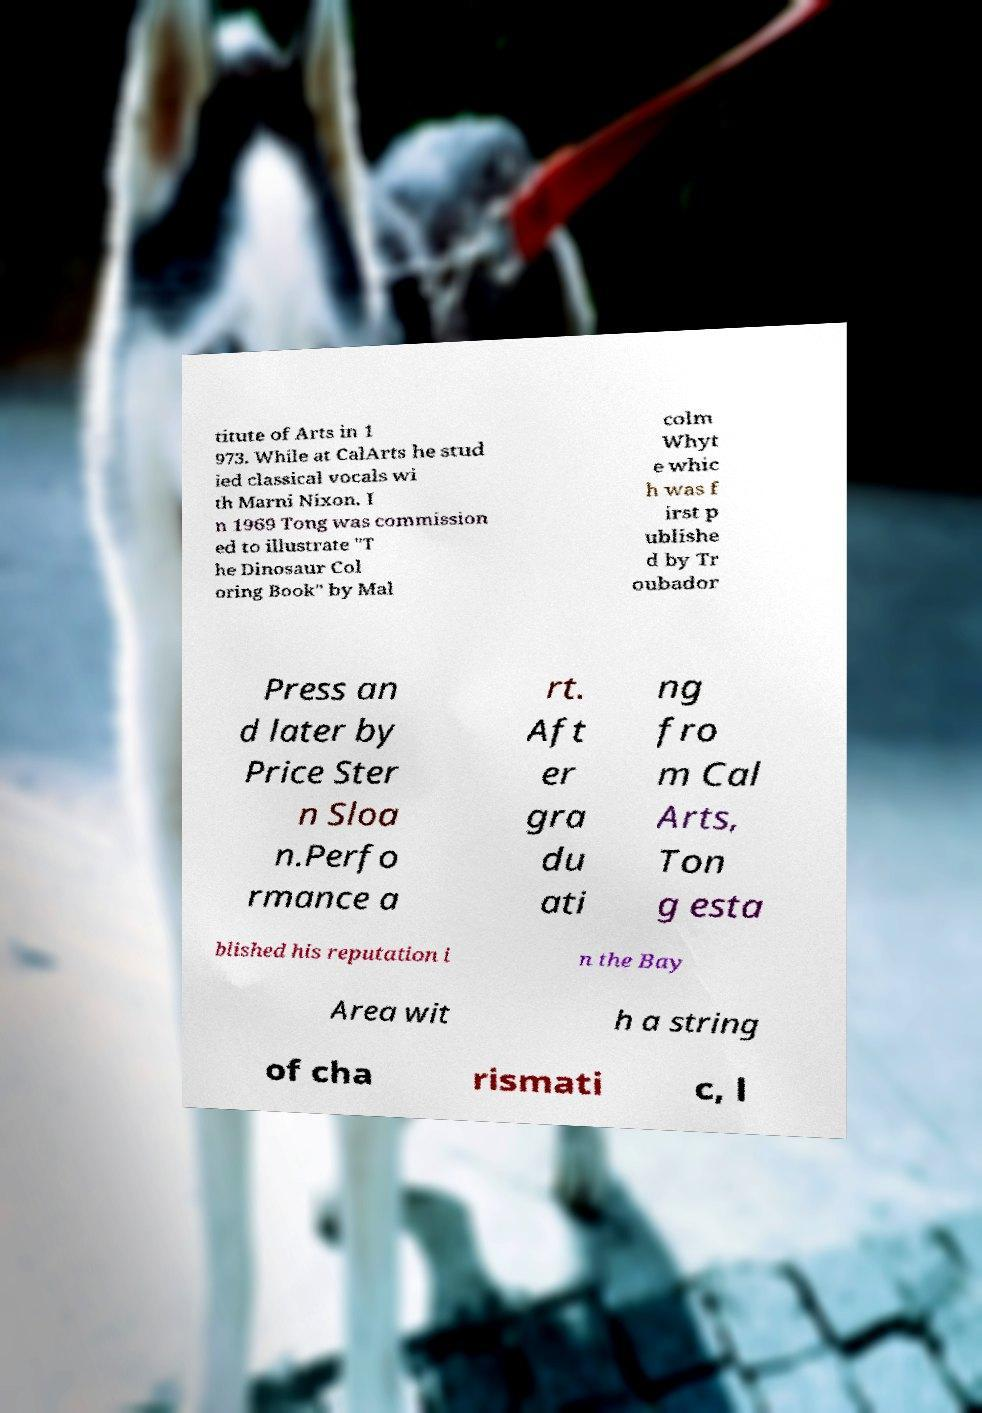Can you read and provide the text displayed in the image?This photo seems to have some interesting text. Can you extract and type it out for me? titute of Arts in 1 973. While at CalArts he stud ied classical vocals wi th Marni Nixon. I n 1969 Tong was commission ed to illustrate "T he Dinosaur Col oring Book" by Mal colm Whyt e whic h was f irst p ublishe d by Tr oubador Press an d later by Price Ster n Sloa n.Perfo rmance a rt. Aft er gra du ati ng fro m Cal Arts, Ton g esta blished his reputation i n the Bay Area wit h a string of cha rismati c, l 